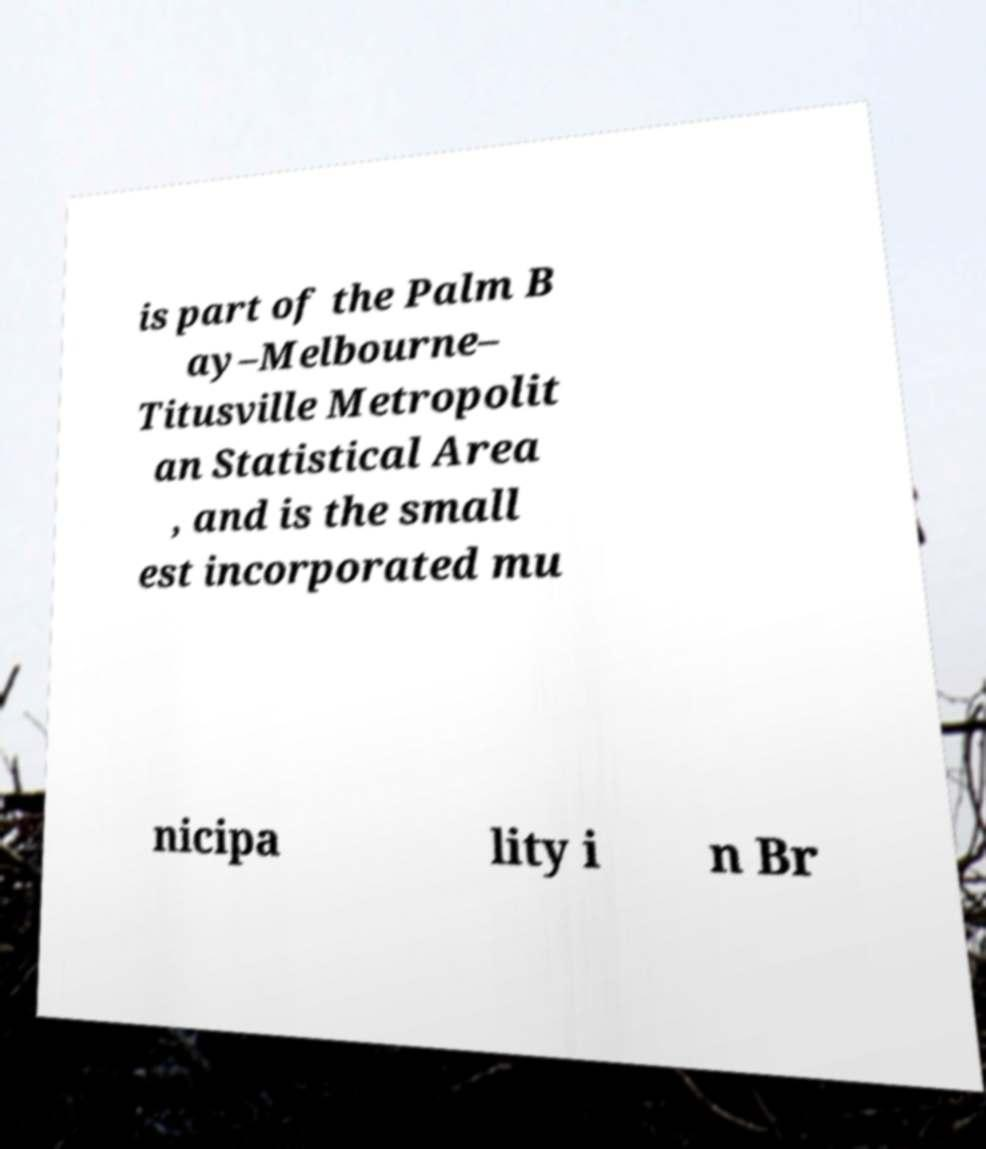Can you read and provide the text displayed in the image?This photo seems to have some interesting text. Can you extract and type it out for me? is part of the Palm B ay–Melbourne– Titusville Metropolit an Statistical Area , and is the small est incorporated mu nicipa lity i n Br 